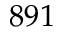<formula> <loc_0><loc_0><loc_500><loc_500>8 9 1</formula> 